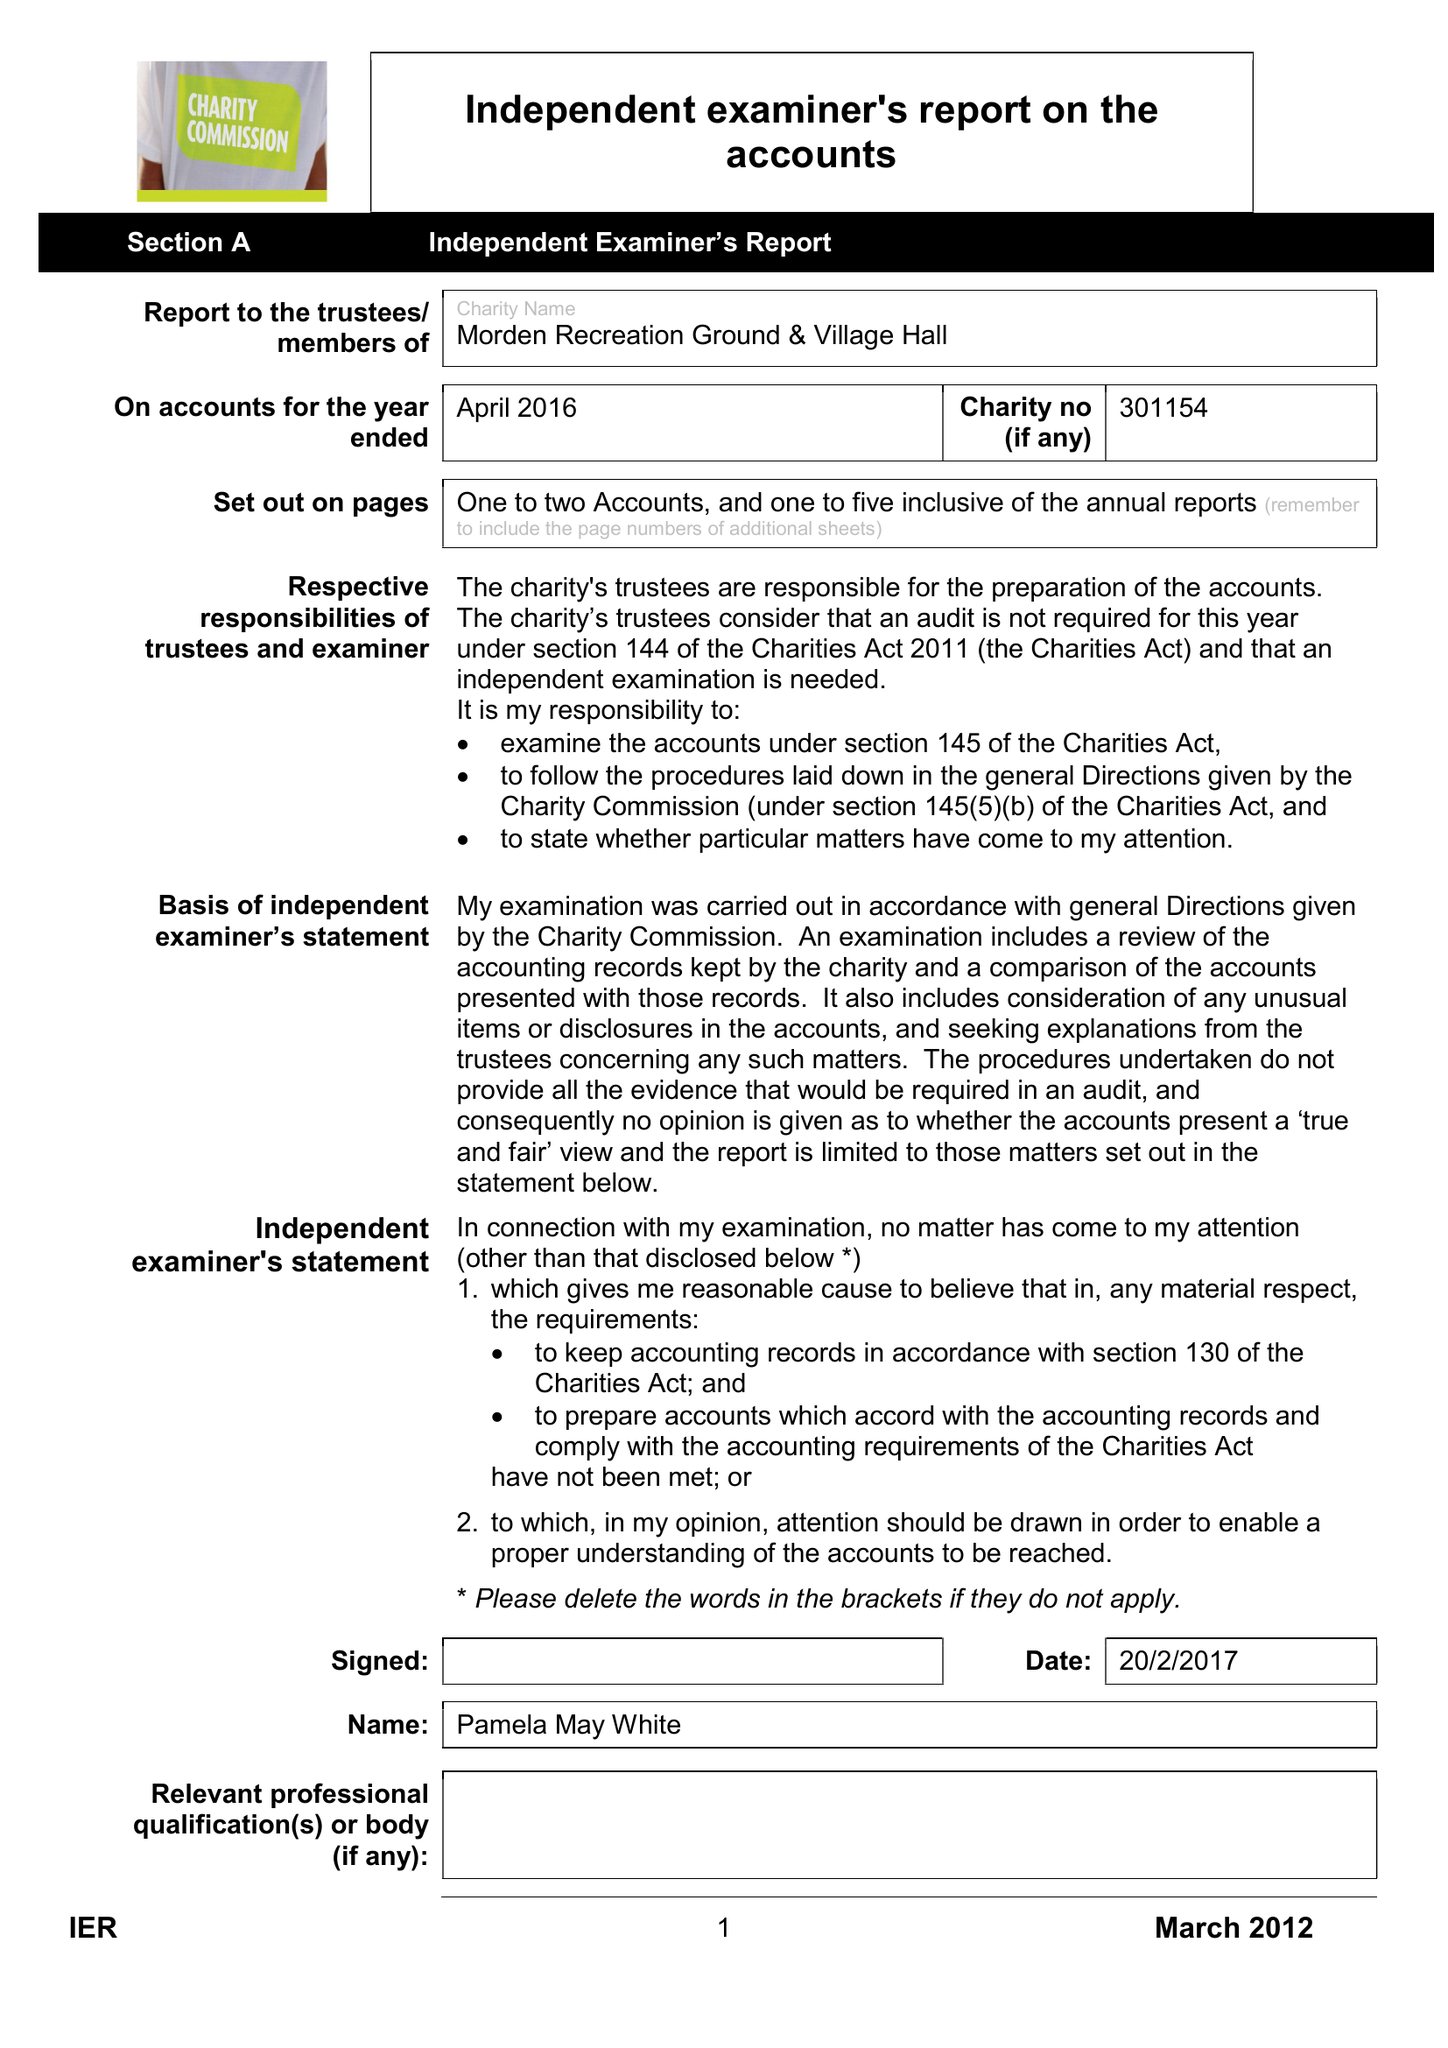What is the value for the charity_name?
Answer the question using a single word or phrase. The Morden Recreation Ground and Village Hall 